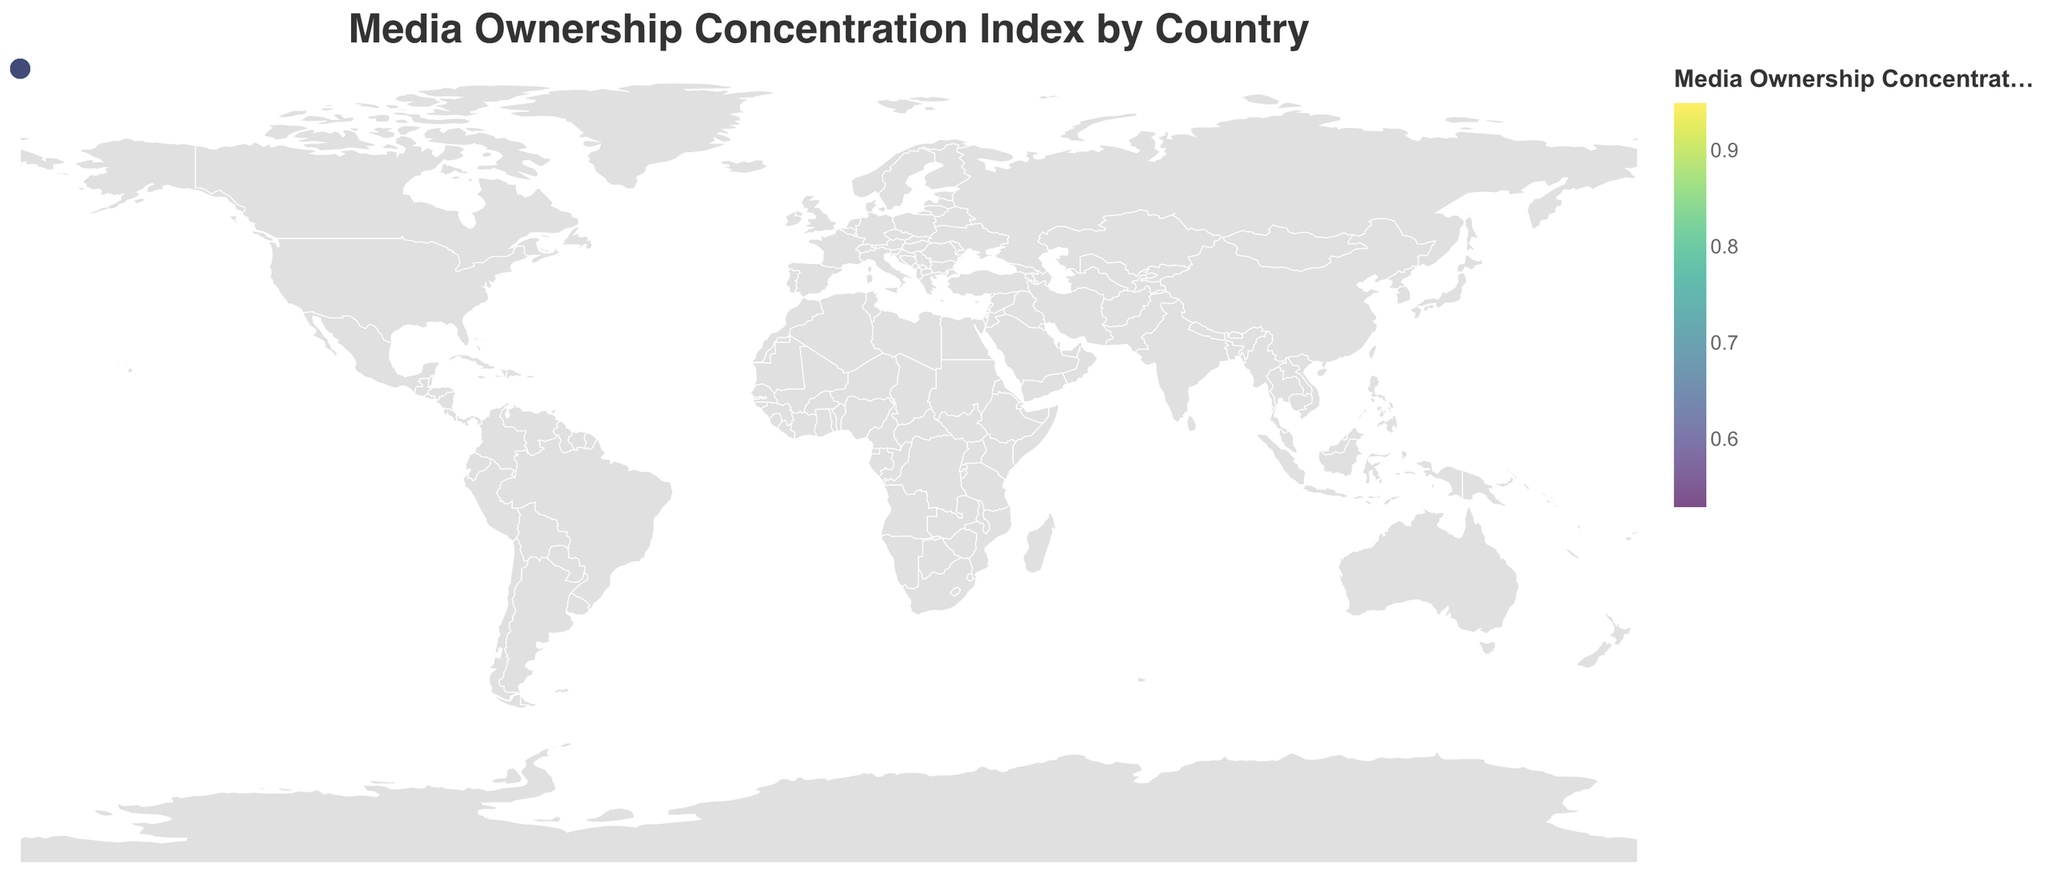What does the title of the figure indicate? The title of the figure is "Media Ownership Concentration Index by Country," indicating that the figure compares the concentration of media ownership across different countries.
Answer: Media Ownership Concentration Index by Country How is the Media Ownership Concentration Index represented in the figure? The Media Ownership Concentration Index is represented by the color of the circles on the map. Darker colors indicate a higher concentration index according to the color legend.
Answer: By the color of the circles Which country has the highest Media Ownership Concentration Index in the figure? The country with the highest Media Ownership Concentration Index is China, with an index value of 0.95.
Answer: China Compare the Media Ownership Concentration Index of the United States and Russia. Which country has a higher index, and by how much? The United States has an index of 0.68, while Russia has an index of 0.89. Russia's index is higher by 0.21.
Answer: Russia, by 0.21 List three countries with a Media Ownership Concentration Index greater than 0.80. The countries with an index greater than 0.80 are India (0.82), Turkey (0.81), and China (0.95).
Answer: India, Turkey, China What is the difference in the Media Ownership Concentration Index between Italy and Germany? Italy has an index of 0.75, whereas Germany has an index of 0.59. The difference is 0.16.
Answer: 0.16 Calculate the average Media Ownership Concentration Index of Japan, Australia, and Canada. The index values are Japan (0.61), Australia (0.70), and Canada (0.64). The average is calculated as (0.61 + 0.70 + 0.64) / 3 = 0.65.
Answer: 0.65 Which country has the lowest Media Ownership Concentration Index, and what is the value? Sweden has the lowest Media Ownership Concentration Index, with a value of 0.53.
Answer: Sweden, 0.53 What trend can be observed regarding the concentration index in South American countries? South American countries like Brazil (0.78), Argentina (0.74), and Mexico (0.76) tend to have higher Media Ownership Concentration Index compared to many other regions.
Answer: High concentration index in South America Compare the Media Ownership Concentration Index of South Korea and South Africa. Which one is higher and by how much? South Korea has an index of 0.67, and South Africa has an index of 0.73. South Africa's index is higher by 0.06.
Answer: South Africa, by 0.06 